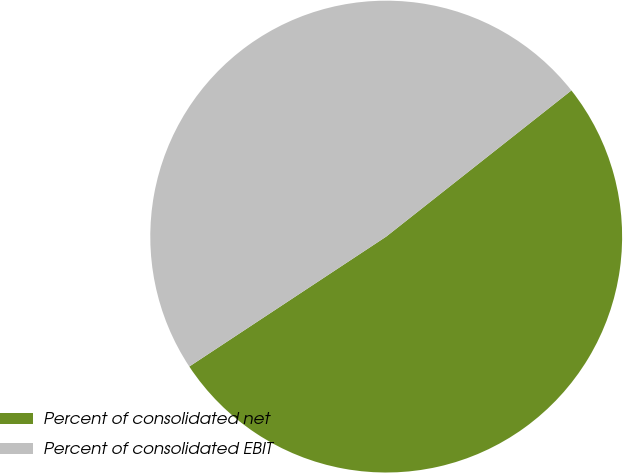Convert chart. <chart><loc_0><loc_0><loc_500><loc_500><pie_chart><fcel>Percent of consolidated net<fcel>Percent of consolidated EBIT<nl><fcel>51.35%<fcel>48.65%<nl></chart> 